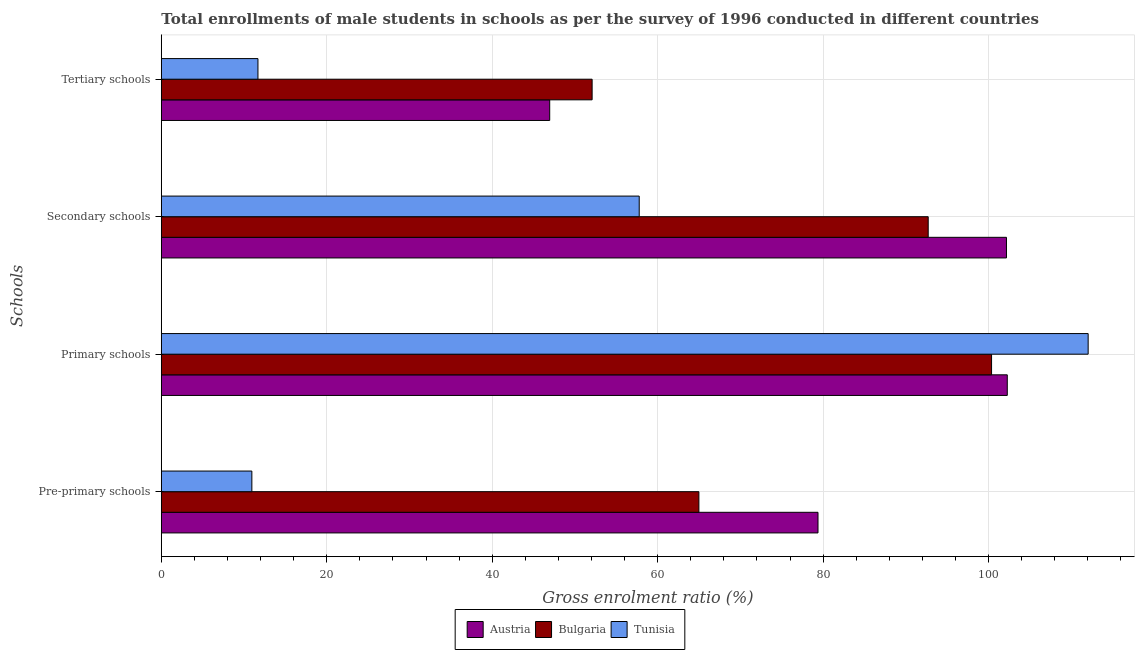How many different coloured bars are there?
Make the answer very short. 3. What is the label of the 2nd group of bars from the top?
Offer a terse response. Secondary schools. What is the gross enrolment ratio(male) in pre-primary schools in Bulgaria?
Ensure brevity in your answer.  64.98. Across all countries, what is the maximum gross enrolment ratio(male) in pre-primary schools?
Offer a very short reply. 79.38. Across all countries, what is the minimum gross enrolment ratio(male) in secondary schools?
Your answer should be compact. 57.77. In which country was the gross enrolment ratio(male) in primary schools maximum?
Provide a succinct answer. Tunisia. In which country was the gross enrolment ratio(male) in tertiary schools minimum?
Your response must be concise. Tunisia. What is the total gross enrolment ratio(male) in tertiary schools in the graph?
Make the answer very short. 110.71. What is the difference between the gross enrolment ratio(male) in secondary schools in Tunisia and that in Bulgaria?
Give a very brief answer. -34.93. What is the difference between the gross enrolment ratio(male) in tertiary schools in Bulgaria and the gross enrolment ratio(male) in secondary schools in Tunisia?
Make the answer very short. -5.69. What is the average gross enrolment ratio(male) in primary schools per country?
Keep it short and to the point. 104.89. What is the difference between the gross enrolment ratio(male) in tertiary schools and gross enrolment ratio(male) in pre-primary schools in Bulgaria?
Give a very brief answer. -12.91. In how many countries, is the gross enrolment ratio(male) in tertiary schools greater than 68 %?
Your response must be concise. 0. What is the ratio of the gross enrolment ratio(male) in tertiary schools in Austria to that in Tunisia?
Your response must be concise. 4.02. Is the gross enrolment ratio(male) in primary schools in Bulgaria less than that in Austria?
Keep it short and to the point. Yes. Is the difference between the gross enrolment ratio(male) in primary schools in Austria and Bulgaria greater than the difference between the gross enrolment ratio(male) in tertiary schools in Austria and Bulgaria?
Provide a short and direct response. Yes. What is the difference between the highest and the second highest gross enrolment ratio(male) in tertiary schools?
Provide a succinct answer. 5.13. What is the difference between the highest and the lowest gross enrolment ratio(male) in primary schools?
Your answer should be very brief. 11.67. Is it the case that in every country, the sum of the gross enrolment ratio(male) in primary schools and gross enrolment ratio(male) in secondary schools is greater than the sum of gross enrolment ratio(male) in pre-primary schools and gross enrolment ratio(male) in tertiary schools?
Your answer should be compact. Yes. What does the 2nd bar from the top in Tertiary schools represents?
Keep it short and to the point. Bulgaria. Is it the case that in every country, the sum of the gross enrolment ratio(male) in pre-primary schools and gross enrolment ratio(male) in primary schools is greater than the gross enrolment ratio(male) in secondary schools?
Your response must be concise. Yes. How many bars are there?
Offer a terse response. 12. How many countries are there in the graph?
Your response must be concise. 3. What is the difference between two consecutive major ticks on the X-axis?
Your answer should be compact. 20. Are the values on the major ticks of X-axis written in scientific E-notation?
Your response must be concise. No. How are the legend labels stacked?
Your answer should be very brief. Horizontal. What is the title of the graph?
Provide a short and direct response. Total enrollments of male students in schools as per the survey of 1996 conducted in different countries. What is the label or title of the Y-axis?
Your response must be concise. Schools. What is the Gross enrolment ratio (%) of Austria in Pre-primary schools?
Your answer should be compact. 79.38. What is the Gross enrolment ratio (%) in Bulgaria in Pre-primary schools?
Provide a short and direct response. 64.98. What is the Gross enrolment ratio (%) in Tunisia in Pre-primary schools?
Make the answer very short. 10.94. What is the Gross enrolment ratio (%) of Austria in Primary schools?
Your response must be concise. 102.26. What is the Gross enrolment ratio (%) of Bulgaria in Primary schools?
Your response must be concise. 100.36. What is the Gross enrolment ratio (%) of Tunisia in Primary schools?
Your answer should be very brief. 112.04. What is the Gross enrolment ratio (%) in Austria in Secondary schools?
Provide a succinct answer. 102.16. What is the Gross enrolment ratio (%) in Bulgaria in Secondary schools?
Offer a terse response. 92.7. What is the Gross enrolment ratio (%) in Tunisia in Secondary schools?
Offer a terse response. 57.77. What is the Gross enrolment ratio (%) in Austria in Tertiary schools?
Provide a short and direct response. 46.95. What is the Gross enrolment ratio (%) in Bulgaria in Tertiary schools?
Make the answer very short. 52.08. What is the Gross enrolment ratio (%) of Tunisia in Tertiary schools?
Offer a very short reply. 11.68. Across all Schools, what is the maximum Gross enrolment ratio (%) of Austria?
Keep it short and to the point. 102.26. Across all Schools, what is the maximum Gross enrolment ratio (%) of Bulgaria?
Your response must be concise. 100.36. Across all Schools, what is the maximum Gross enrolment ratio (%) in Tunisia?
Offer a very short reply. 112.04. Across all Schools, what is the minimum Gross enrolment ratio (%) in Austria?
Ensure brevity in your answer.  46.95. Across all Schools, what is the minimum Gross enrolment ratio (%) of Bulgaria?
Offer a terse response. 52.08. Across all Schools, what is the minimum Gross enrolment ratio (%) in Tunisia?
Make the answer very short. 10.94. What is the total Gross enrolment ratio (%) in Austria in the graph?
Offer a very short reply. 330.75. What is the total Gross enrolment ratio (%) of Bulgaria in the graph?
Keep it short and to the point. 310.12. What is the total Gross enrolment ratio (%) of Tunisia in the graph?
Your response must be concise. 192.43. What is the difference between the Gross enrolment ratio (%) of Austria in Pre-primary schools and that in Primary schools?
Offer a terse response. -22.88. What is the difference between the Gross enrolment ratio (%) in Bulgaria in Pre-primary schools and that in Primary schools?
Give a very brief answer. -35.38. What is the difference between the Gross enrolment ratio (%) in Tunisia in Pre-primary schools and that in Primary schools?
Your answer should be very brief. -101.09. What is the difference between the Gross enrolment ratio (%) of Austria in Pre-primary schools and that in Secondary schools?
Provide a short and direct response. -22.78. What is the difference between the Gross enrolment ratio (%) in Bulgaria in Pre-primary schools and that in Secondary schools?
Your answer should be compact. -27.72. What is the difference between the Gross enrolment ratio (%) of Tunisia in Pre-primary schools and that in Secondary schools?
Keep it short and to the point. -46.82. What is the difference between the Gross enrolment ratio (%) of Austria in Pre-primary schools and that in Tertiary schools?
Make the answer very short. 32.43. What is the difference between the Gross enrolment ratio (%) in Bulgaria in Pre-primary schools and that in Tertiary schools?
Offer a terse response. 12.91. What is the difference between the Gross enrolment ratio (%) in Tunisia in Pre-primary schools and that in Tertiary schools?
Your answer should be compact. -0.74. What is the difference between the Gross enrolment ratio (%) of Austria in Primary schools and that in Secondary schools?
Make the answer very short. 0.1. What is the difference between the Gross enrolment ratio (%) of Bulgaria in Primary schools and that in Secondary schools?
Give a very brief answer. 7.66. What is the difference between the Gross enrolment ratio (%) of Tunisia in Primary schools and that in Secondary schools?
Keep it short and to the point. 54.27. What is the difference between the Gross enrolment ratio (%) in Austria in Primary schools and that in Tertiary schools?
Your answer should be compact. 55.31. What is the difference between the Gross enrolment ratio (%) in Bulgaria in Primary schools and that in Tertiary schools?
Give a very brief answer. 48.29. What is the difference between the Gross enrolment ratio (%) in Tunisia in Primary schools and that in Tertiary schools?
Your answer should be very brief. 100.35. What is the difference between the Gross enrolment ratio (%) of Austria in Secondary schools and that in Tertiary schools?
Your answer should be very brief. 55.21. What is the difference between the Gross enrolment ratio (%) of Bulgaria in Secondary schools and that in Tertiary schools?
Ensure brevity in your answer.  40.63. What is the difference between the Gross enrolment ratio (%) in Tunisia in Secondary schools and that in Tertiary schools?
Your answer should be very brief. 46.09. What is the difference between the Gross enrolment ratio (%) in Austria in Pre-primary schools and the Gross enrolment ratio (%) in Bulgaria in Primary schools?
Offer a terse response. -20.98. What is the difference between the Gross enrolment ratio (%) in Austria in Pre-primary schools and the Gross enrolment ratio (%) in Tunisia in Primary schools?
Your answer should be compact. -32.66. What is the difference between the Gross enrolment ratio (%) in Bulgaria in Pre-primary schools and the Gross enrolment ratio (%) in Tunisia in Primary schools?
Make the answer very short. -47.05. What is the difference between the Gross enrolment ratio (%) in Austria in Pre-primary schools and the Gross enrolment ratio (%) in Bulgaria in Secondary schools?
Your response must be concise. -13.32. What is the difference between the Gross enrolment ratio (%) of Austria in Pre-primary schools and the Gross enrolment ratio (%) of Tunisia in Secondary schools?
Provide a succinct answer. 21.61. What is the difference between the Gross enrolment ratio (%) of Bulgaria in Pre-primary schools and the Gross enrolment ratio (%) of Tunisia in Secondary schools?
Ensure brevity in your answer.  7.21. What is the difference between the Gross enrolment ratio (%) in Austria in Pre-primary schools and the Gross enrolment ratio (%) in Bulgaria in Tertiary schools?
Give a very brief answer. 27.3. What is the difference between the Gross enrolment ratio (%) in Austria in Pre-primary schools and the Gross enrolment ratio (%) in Tunisia in Tertiary schools?
Provide a short and direct response. 67.7. What is the difference between the Gross enrolment ratio (%) in Bulgaria in Pre-primary schools and the Gross enrolment ratio (%) in Tunisia in Tertiary schools?
Provide a short and direct response. 53.3. What is the difference between the Gross enrolment ratio (%) in Austria in Primary schools and the Gross enrolment ratio (%) in Bulgaria in Secondary schools?
Offer a terse response. 9.56. What is the difference between the Gross enrolment ratio (%) of Austria in Primary schools and the Gross enrolment ratio (%) of Tunisia in Secondary schools?
Provide a short and direct response. 44.49. What is the difference between the Gross enrolment ratio (%) in Bulgaria in Primary schools and the Gross enrolment ratio (%) in Tunisia in Secondary schools?
Provide a short and direct response. 42.59. What is the difference between the Gross enrolment ratio (%) in Austria in Primary schools and the Gross enrolment ratio (%) in Bulgaria in Tertiary schools?
Provide a short and direct response. 50.19. What is the difference between the Gross enrolment ratio (%) in Austria in Primary schools and the Gross enrolment ratio (%) in Tunisia in Tertiary schools?
Your answer should be compact. 90.58. What is the difference between the Gross enrolment ratio (%) in Bulgaria in Primary schools and the Gross enrolment ratio (%) in Tunisia in Tertiary schools?
Ensure brevity in your answer.  88.68. What is the difference between the Gross enrolment ratio (%) in Austria in Secondary schools and the Gross enrolment ratio (%) in Bulgaria in Tertiary schools?
Provide a succinct answer. 50.09. What is the difference between the Gross enrolment ratio (%) in Austria in Secondary schools and the Gross enrolment ratio (%) in Tunisia in Tertiary schools?
Your answer should be very brief. 90.48. What is the difference between the Gross enrolment ratio (%) of Bulgaria in Secondary schools and the Gross enrolment ratio (%) of Tunisia in Tertiary schools?
Keep it short and to the point. 81.02. What is the average Gross enrolment ratio (%) of Austria per Schools?
Keep it short and to the point. 82.69. What is the average Gross enrolment ratio (%) in Bulgaria per Schools?
Your answer should be compact. 77.53. What is the average Gross enrolment ratio (%) of Tunisia per Schools?
Give a very brief answer. 48.11. What is the difference between the Gross enrolment ratio (%) of Austria and Gross enrolment ratio (%) of Bulgaria in Pre-primary schools?
Offer a terse response. 14.4. What is the difference between the Gross enrolment ratio (%) in Austria and Gross enrolment ratio (%) in Tunisia in Pre-primary schools?
Provide a succinct answer. 68.44. What is the difference between the Gross enrolment ratio (%) in Bulgaria and Gross enrolment ratio (%) in Tunisia in Pre-primary schools?
Your answer should be compact. 54.04. What is the difference between the Gross enrolment ratio (%) in Austria and Gross enrolment ratio (%) in Bulgaria in Primary schools?
Make the answer very short. 1.9. What is the difference between the Gross enrolment ratio (%) of Austria and Gross enrolment ratio (%) of Tunisia in Primary schools?
Offer a terse response. -9.77. What is the difference between the Gross enrolment ratio (%) in Bulgaria and Gross enrolment ratio (%) in Tunisia in Primary schools?
Your answer should be compact. -11.67. What is the difference between the Gross enrolment ratio (%) of Austria and Gross enrolment ratio (%) of Bulgaria in Secondary schools?
Offer a very short reply. 9.46. What is the difference between the Gross enrolment ratio (%) of Austria and Gross enrolment ratio (%) of Tunisia in Secondary schools?
Provide a succinct answer. 44.39. What is the difference between the Gross enrolment ratio (%) of Bulgaria and Gross enrolment ratio (%) of Tunisia in Secondary schools?
Provide a succinct answer. 34.93. What is the difference between the Gross enrolment ratio (%) in Austria and Gross enrolment ratio (%) in Bulgaria in Tertiary schools?
Offer a very short reply. -5.13. What is the difference between the Gross enrolment ratio (%) in Austria and Gross enrolment ratio (%) in Tunisia in Tertiary schools?
Offer a very short reply. 35.27. What is the difference between the Gross enrolment ratio (%) in Bulgaria and Gross enrolment ratio (%) in Tunisia in Tertiary schools?
Your answer should be very brief. 40.39. What is the ratio of the Gross enrolment ratio (%) in Austria in Pre-primary schools to that in Primary schools?
Offer a terse response. 0.78. What is the ratio of the Gross enrolment ratio (%) in Bulgaria in Pre-primary schools to that in Primary schools?
Ensure brevity in your answer.  0.65. What is the ratio of the Gross enrolment ratio (%) of Tunisia in Pre-primary schools to that in Primary schools?
Your response must be concise. 0.1. What is the ratio of the Gross enrolment ratio (%) of Austria in Pre-primary schools to that in Secondary schools?
Your answer should be very brief. 0.78. What is the ratio of the Gross enrolment ratio (%) of Bulgaria in Pre-primary schools to that in Secondary schools?
Your response must be concise. 0.7. What is the ratio of the Gross enrolment ratio (%) of Tunisia in Pre-primary schools to that in Secondary schools?
Provide a succinct answer. 0.19. What is the ratio of the Gross enrolment ratio (%) in Austria in Pre-primary schools to that in Tertiary schools?
Offer a terse response. 1.69. What is the ratio of the Gross enrolment ratio (%) in Bulgaria in Pre-primary schools to that in Tertiary schools?
Make the answer very short. 1.25. What is the ratio of the Gross enrolment ratio (%) in Tunisia in Pre-primary schools to that in Tertiary schools?
Keep it short and to the point. 0.94. What is the ratio of the Gross enrolment ratio (%) in Austria in Primary schools to that in Secondary schools?
Your response must be concise. 1. What is the ratio of the Gross enrolment ratio (%) in Bulgaria in Primary schools to that in Secondary schools?
Provide a succinct answer. 1.08. What is the ratio of the Gross enrolment ratio (%) of Tunisia in Primary schools to that in Secondary schools?
Your response must be concise. 1.94. What is the ratio of the Gross enrolment ratio (%) of Austria in Primary schools to that in Tertiary schools?
Your answer should be very brief. 2.18. What is the ratio of the Gross enrolment ratio (%) of Bulgaria in Primary schools to that in Tertiary schools?
Keep it short and to the point. 1.93. What is the ratio of the Gross enrolment ratio (%) of Tunisia in Primary schools to that in Tertiary schools?
Make the answer very short. 9.59. What is the ratio of the Gross enrolment ratio (%) in Austria in Secondary schools to that in Tertiary schools?
Your answer should be very brief. 2.18. What is the ratio of the Gross enrolment ratio (%) in Bulgaria in Secondary schools to that in Tertiary schools?
Your answer should be very brief. 1.78. What is the ratio of the Gross enrolment ratio (%) in Tunisia in Secondary schools to that in Tertiary schools?
Keep it short and to the point. 4.95. What is the difference between the highest and the second highest Gross enrolment ratio (%) of Austria?
Provide a short and direct response. 0.1. What is the difference between the highest and the second highest Gross enrolment ratio (%) in Bulgaria?
Provide a short and direct response. 7.66. What is the difference between the highest and the second highest Gross enrolment ratio (%) of Tunisia?
Provide a short and direct response. 54.27. What is the difference between the highest and the lowest Gross enrolment ratio (%) of Austria?
Your response must be concise. 55.31. What is the difference between the highest and the lowest Gross enrolment ratio (%) of Bulgaria?
Make the answer very short. 48.29. What is the difference between the highest and the lowest Gross enrolment ratio (%) of Tunisia?
Keep it short and to the point. 101.09. 